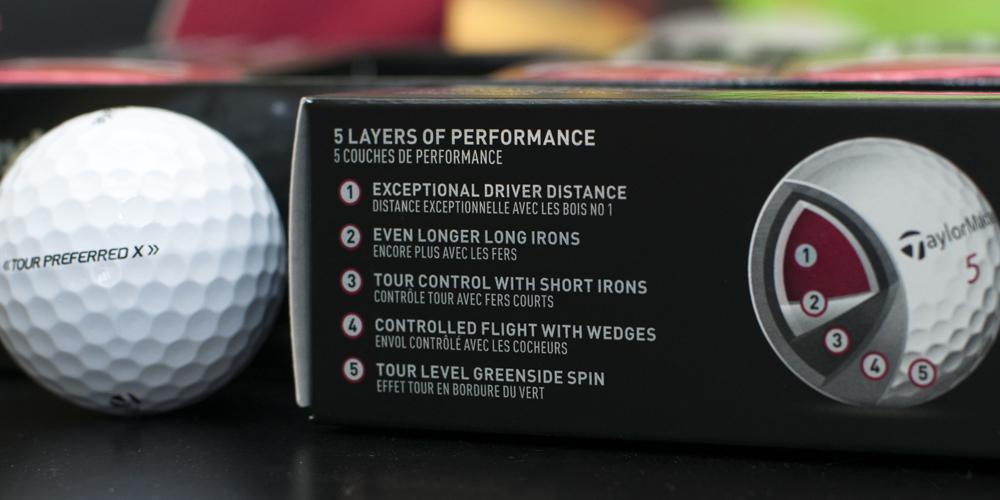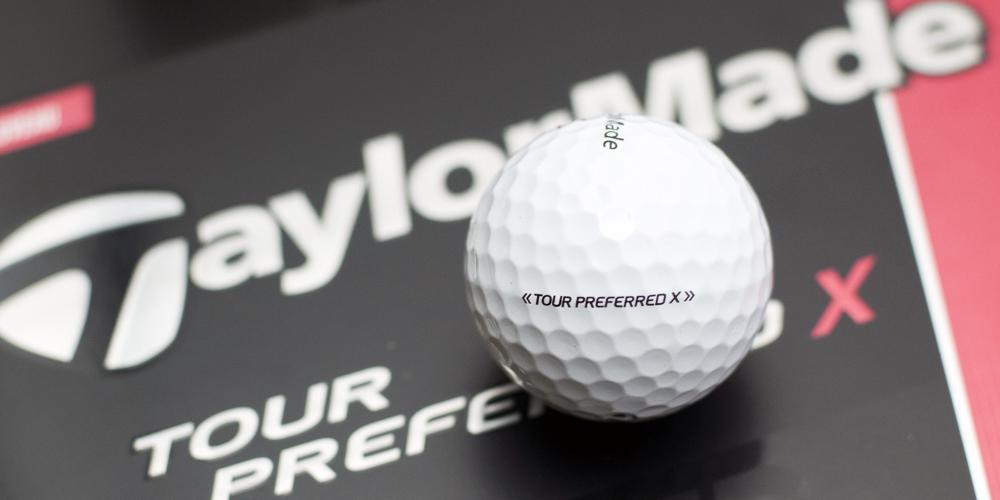The first image is the image on the left, the second image is the image on the right. Considering the images on both sides, is "All golf balls are in boxes, a total of at least nine boxes of balls are shown, and some boxes have hexagon 'windows' at the center." valid? Answer yes or no. No. The first image is the image on the left, the second image is the image on the right. For the images displayed, is the sentence "All the golf balls are in boxes." factually correct? Answer yes or no. No. 